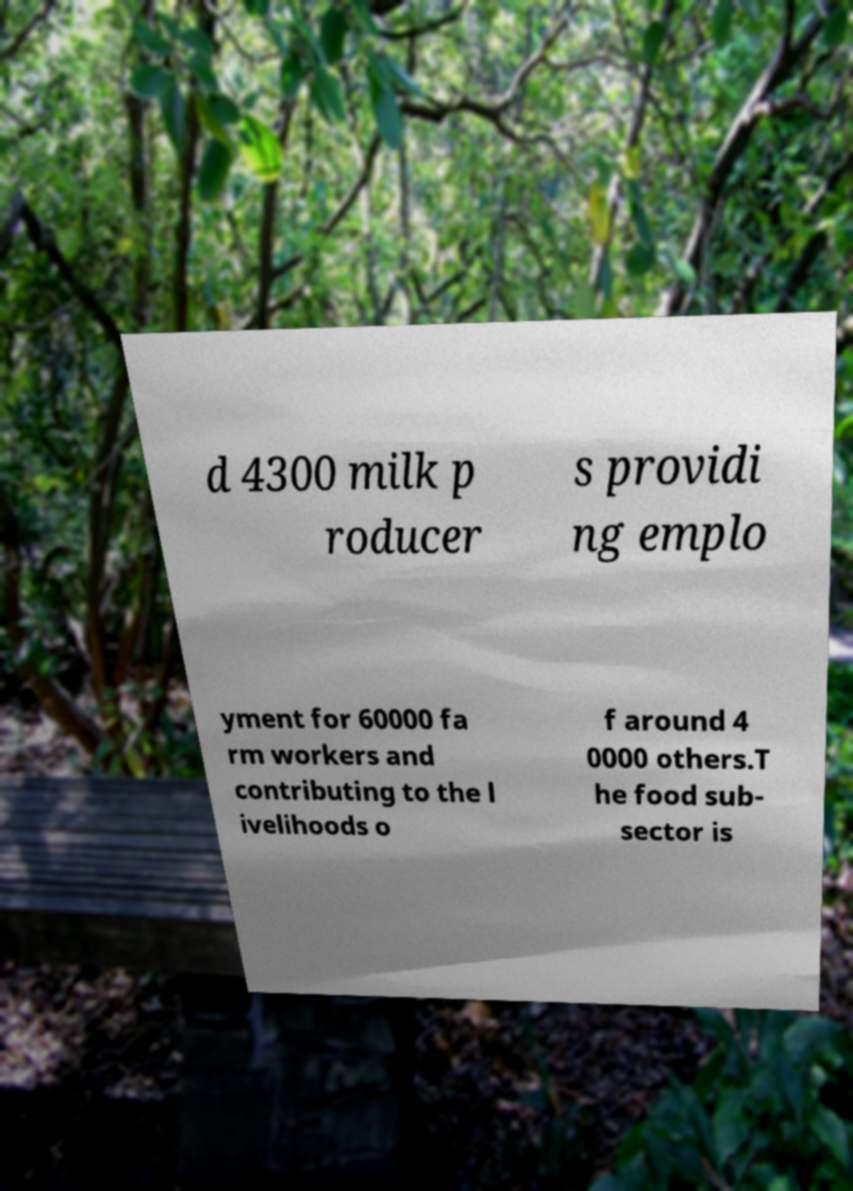I need the written content from this picture converted into text. Can you do that? d 4300 milk p roducer s providi ng emplo yment for 60000 fa rm workers and contributing to the l ivelihoods o f around 4 0000 others.T he food sub- sector is 